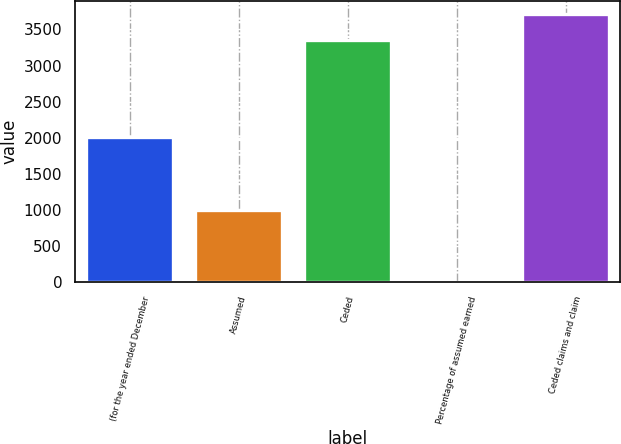Convert chart to OTSL. <chart><loc_0><loc_0><loc_500><loc_500><bar_chart><fcel>(for the year ended December<fcel>Assumed<fcel>Ceded<fcel>Percentage of assumed earned<fcel>Ceded claims and claim<nl><fcel>2005<fcel>995<fcel>3350<fcel>5.3<fcel>3709.57<nl></chart> 